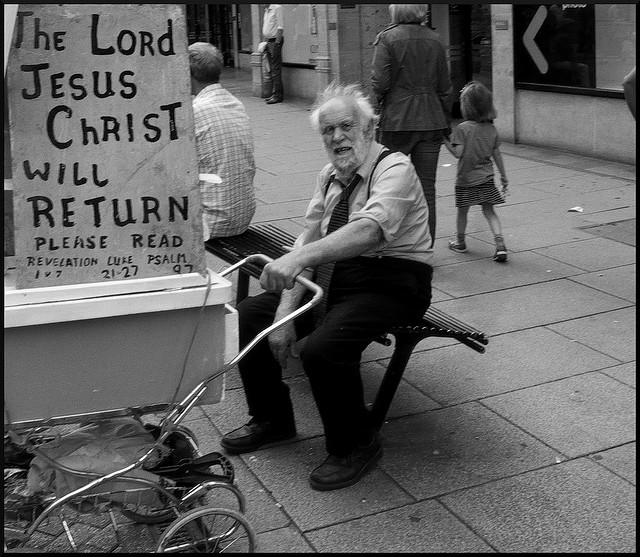What book is the man's sign referencing? bible 